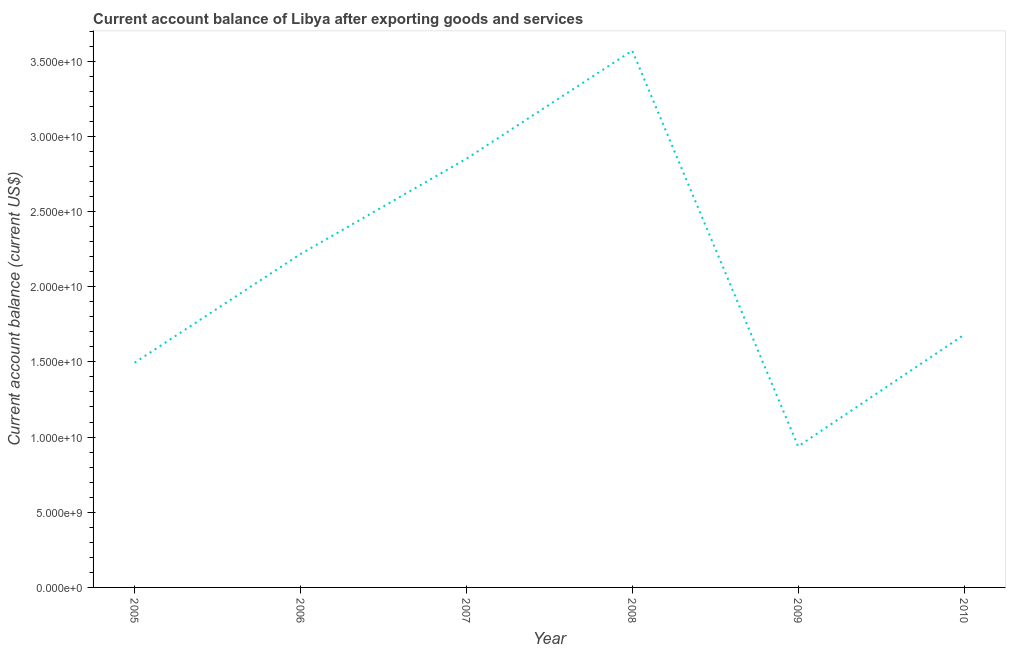What is the current account balance in 2007?
Offer a terse response. 2.85e+1. Across all years, what is the maximum current account balance?
Keep it short and to the point. 3.57e+1. Across all years, what is the minimum current account balance?
Provide a short and direct response. 9.38e+09. In which year was the current account balance maximum?
Provide a short and direct response. 2008. In which year was the current account balance minimum?
Ensure brevity in your answer.  2009. What is the sum of the current account balance?
Your answer should be very brief. 1.28e+11. What is the difference between the current account balance in 2006 and 2007?
Your answer should be very brief. -6.34e+09. What is the average current account balance per year?
Offer a terse response. 2.13e+1. What is the median current account balance?
Provide a succinct answer. 1.95e+1. Do a majority of the years between 2005 and 2007 (inclusive) have current account balance greater than 30000000000 US$?
Your answer should be compact. No. What is the ratio of the current account balance in 2005 to that in 2009?
Keep it short and to the point. 1.59. Is the current account balance in 2007 less than that in 2009?
Give a very brief answer. No. Is the difference between the current account balance in 2005 and 2009 greater than the difference between any two years?
Provide a succinct answer. No. What is the difference between the highest and the second highest current account balance?
Your response must be concise. 7.19e+09. Is the sum of the current account balance in 2008 and 2010 greater than the maximum current account balance across all years?
Make the answer very short. Yes. What is the difference between the highest and the lowest current account balance?
Your response must be concise. 2.63e+1. In how many years, is the current account balance greater than the average current account balance taken over all years?
Offer a very short reply. 3. Does the current account balance monotonically increase over the years?
Offer a very short reply. No. How many years are there in the graph?
Give a very brief answer. 6. What is the difference between two consecutive major ticks on the Y-axis?
Provide a short and direct response. 5.00e+09. Are the values on the major ticks of Y-axis written in scientific E-notation?
Your answer should be very brief. Yes. Does the graph contain any zero values?
Provide a short and direct response. No. What is the title of the graph?
Offer a terse response. Current account balance of Libya after exporting goods and services. What is the label or title of the X-axis?
Offer a terse response. Year. What is the label or title of the Y-axis?
Ensure brevity in your answer.  Current account balance (current US$). What is the Current account balance (current US$) in 2005?
Keep it short and to the point. 1.49e+1. What is the Current account balance (current US$) in 2006?
Offer a terse response. 2.22e+1. What is the Current account balance (current US$) of 2007?
Give a very brief answer. 2.85e+1. What is the Current account balance (current US$) in 2008?
Keep it short and to the point. 3.57e+1. What is the Current account balance (current US$) of 2009?
Give a very brief answer. 9.38e+09. What is the Current account balance (current US$) of 2010?
Ensure brevity in your answer.  1.68e+1. What is the difference between the Current account balance (current US$) in 2005 and 2006?
Give a very brief answer. -7.22e+09. What is the difference between the Current account balance (current US$) in 2005 and 2007?
Ensure brevity in your answer.  -1.36e+1. What is the difference between the Current account balance (current US$) in 2005 and 2008?
Your answer should be very brief. -2.08e+1. What is the difference between the Current account balance (current US$) in 2005 and 2009?
Offer a very short reply. 5.56e+09. What is the difference between the Current account balance (current US$) in 2005 and 2010?
Provide a short and direct response. -1.86e+09. What is the difference between the Current account balance (current US$) in 2006 and 2007?
Ensure brevity in your answer.  -6.34e+09. What is the difference between the Current account balance (current US$) in 2006 and 2008?
Ensure brevity in your answer.  -1.35e+1. What is the difference between the Current account balance (current US$) in 2006 and 2009?
Ensure brevity in your answer.  1.28e+1. What is the difference between the Current account balance (current US$) in 2006 and 2010?
Make the answer very short. 5.37e+09. What is the difference between the Current account balance (current US$) in 2007 and 2008?
Provide a succinct answer. -7.19e+09. What is the difference between the Current account balance (current US$) in 2007 and 2009?
Provide a succinct answer. 1.91e+1. What is the difference between the Current account balance (current US$) in 2007 and 2010?
Give a very brief answer. 1.17e+1. What is the difference between the Current account balance (current US$) in 2008 and 2009?
Your answer should be compact. 2.63e+1. What is the difference between the Current account balance (current US$) in 2008 and 2010?
Give a very brief answer. 1.89e+1. What is the difference between the Current account balance (current US$) in 2009 and 2010?
Offer a very short reply. -7.42e+09. What is the ratio of the Current account balance (current US$) in 2005 to that in 2006?
Keep it short and to the point. 0.67. What is the ratio of the Current account balance (current US$) in 2005 to that in 2007?
Ensure brevity in your answer.  0.52. What is the ratio of the Current account balance (current US$) in 2005 to that in 2008?
Your answer should be compact. 0.42. What is the ratio of the Current account balance (current US$) in 2005 to that in 2009?
Keep it short and to the point. 1.59. What is the ratio of the Current account balance (current US$) in 2005 to that in 2010?
Your response must be concise. 0.89. What is the ratio of the Current account balance (current US$) in 2006 to that in 2007?
Your response must be concise. 0.78. What is the ratio of the Current account balance (current US$) in 2006 to that in 2008?
Offer a terse response. 0.62. What is the ratio of the Current account balance (current US$) in 2006 to that in 2009?
Provide a succinct answer. 2.36. What is the ratio of the Current account balance (current US$) in 2006 to that in 2010?
Your response must be concise. 1.32. What is the ratio of the Current account balance (current US$) in 2007 to that in 2008?
Keep it short and to the point. 0.8. What is the ratio of the Current account balance (current US$) in 2007 to that in 2009?
Your response must be concise. 3.04. What is the ratio of the Current account balance (current US$) in 2007 to that in 2010?
Your response must be concise. 1.7. What is the ratio of the Current account balance (current US$) in 2008 to that in 2009?
Offer a very short reply. 3.81. What is the ratio of the Current account balance (current US$) in 2008 to that in 2010?
Provide a short and direct response. 2.12. What is the ratio of the Current account balance (current US$) in 2009 to that in 2010?
Keep it short and to the point. 0.56. 